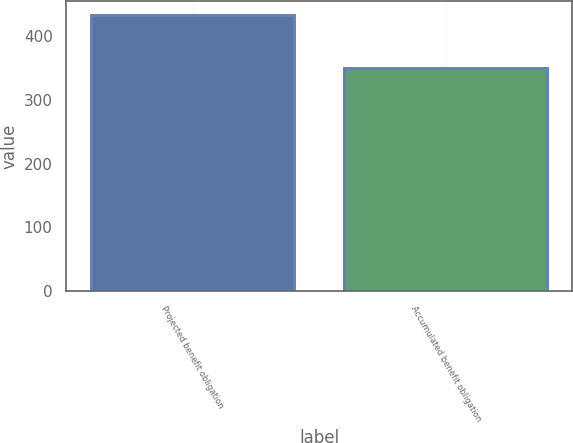Convert chart. <chart><loc_0><loc_0><loc_500><loc_500><bar_chart><fcel>Projected benefit obligation<fcel>Accumulated benefit obligation<nl><fcel>433<fcel>350<nl></chart> 